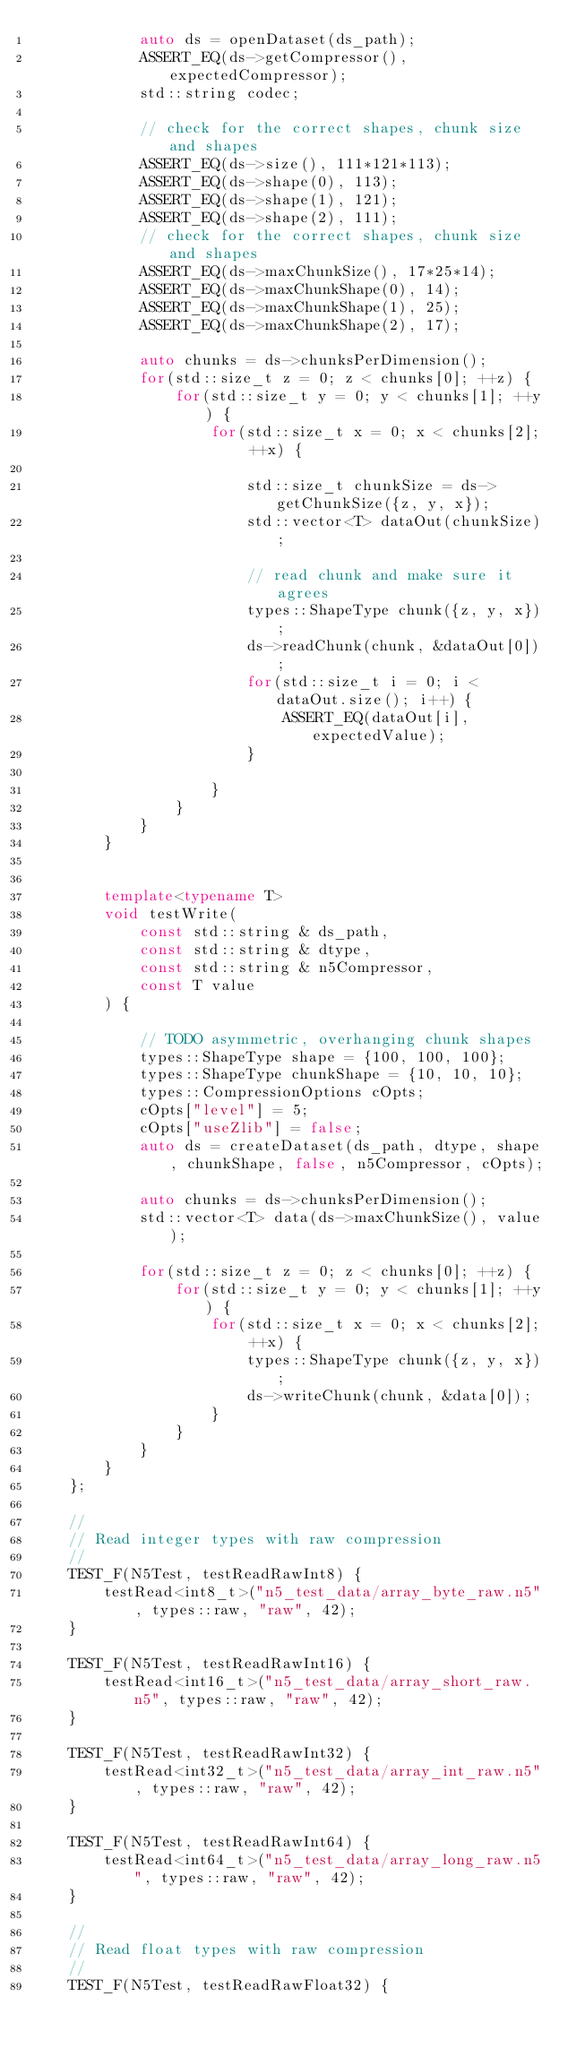<code> <loc_0><loc_0><loc_500><loc_500><_C++_>            auto ds = openDataset(ds_path);
            ASSERT_EQ(ds->getCompressor(), expectedCompressor);
            std::string codec;

            // check for the correct shapes, chunk size and shapes
            ASSERT_EQ(ds->size(), 111*121*113);
            ASSERT_EQ(ds->shape(0), 113);
            ASSERT_EQ(ds->shape(1), 121);
            ASSERT_EQ(ds->shape(2), 111);
            // check for the correct shapes, chunk size and shapes
            ASSERT_EQ(ds->maxChunkSize(), 17*25*14);
            ASSERT_EQ(ds->maxChunkShape(0), 14);
            ASSERT_EQ(ds->maxChunkShape(1), 25);
            ASSERT_EQ(ds->maxChunkShape(2), 17);

            auto chunks = ds->chunksPerDimension();
            for(std::size_t z = 0; z < chunks[0]; ++z) {
                for(std::size_t y = 0; y < chunks[1]; ++y) {
                    for(std::size_t x = 0; x < chunks[2]; ++x) {

                        std::size_t chunkSize = ds->getChunkSize({z, y, x});
                        std::vector<T> dataOut(chunkSize);

                        // read chunk and make sure it agrees
                        types::ShapeType chunk({z, y, x});
                        ds->readChunk(chunk, &dataOut[0]);
                        for(std::size_t i = 0; i < dataOut.size(); i++) {
                            ASSERT_EQ(dataOut[i], expectedValue);
                        }

                    }
                }
            }
        }


        template<typename T>
        void testWrite(
            const std::string & ds_path,
            const std::string & dtype,
            const std::string & n5Compressor,
            const T value
        ) {

            // TODO asymmetric, overhanging chunk shapes
            types::ShapeType shape = {100, 100, 100};
            types::ShapeType chunkShape = {10, 10, 10};
            types::CompressionOptions cOpts;
            cOpts["level"] = 5;
            cOpts["useZlib"] = false;
            auto ds = createDataset(ds_path, dtype, shape, chunkShape, false, n5Compressor, cOpts);

            auto chunks = ds->chunksPerDimension();
            std::vector<T> data(ds->maxChunkSize(), value);

            for(std::size_t z = 0; z < chunks[0]; ++z) {
                for(std::size_t y = 0; y < chunks[1]; ++y) {
                    for(std::size_t x = 0; x < chunks[2]; ++x) {
                        types::ShapeType chunk({z, y, x});
                        ds->writeChunk(chunk, &data[0]);
                    }
                }
            }
        }
    };

    //
    // Read integer types with raw compression
    //
    TEST_F(N5Test, testReadRawInt8) {
        testRead<int8_t>("n5_test_data/array_byte_raw.n5", types::raw, "raw", 42);
    }

    TEST_F(N5Test, testReadRawInt16) {
        testRead<int16_t>("n5_test_data/array_short_raw.n5", types::raw, "raw", 42);
    }

    TEST_F(N5Test, testReadRawInt32) {
        testRead<int32_t>("n5_test_data/array_int_raw.n5", types::raw, "raw", 42);
    }

    TEST_F(N5Test, testReadRawInt64) {
        testRead<int64_t>("n5_test_data/array_long_raw.n5", types::raw, "raw", 42);
    }

    //
    // Read float types with raw compression
    //
    TEST_F(N5Test, testReadRawFloat32) {</code> 